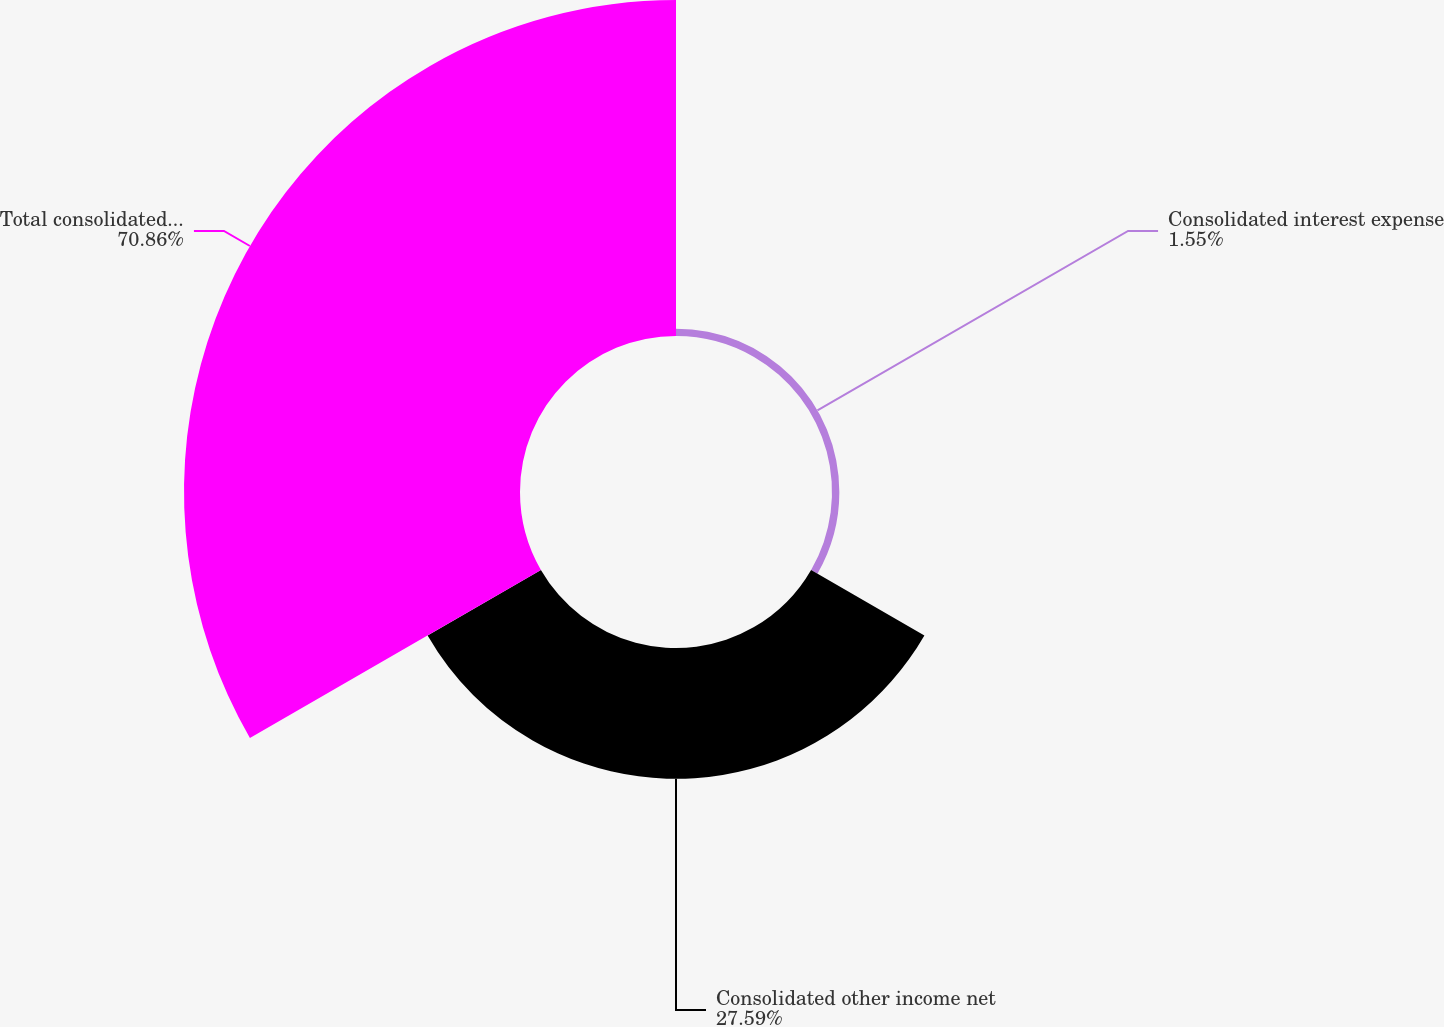<chart> <loc_0><loc_0><loc_500><loc_500><pie_chart><fcel>Consolidated interest expense<fcel>Consolidated other income net<fcel>Total consolidated debt net at<nl><fcel>1.55%<fcel>27.59%<fcel>70.86%<nl></chart> 